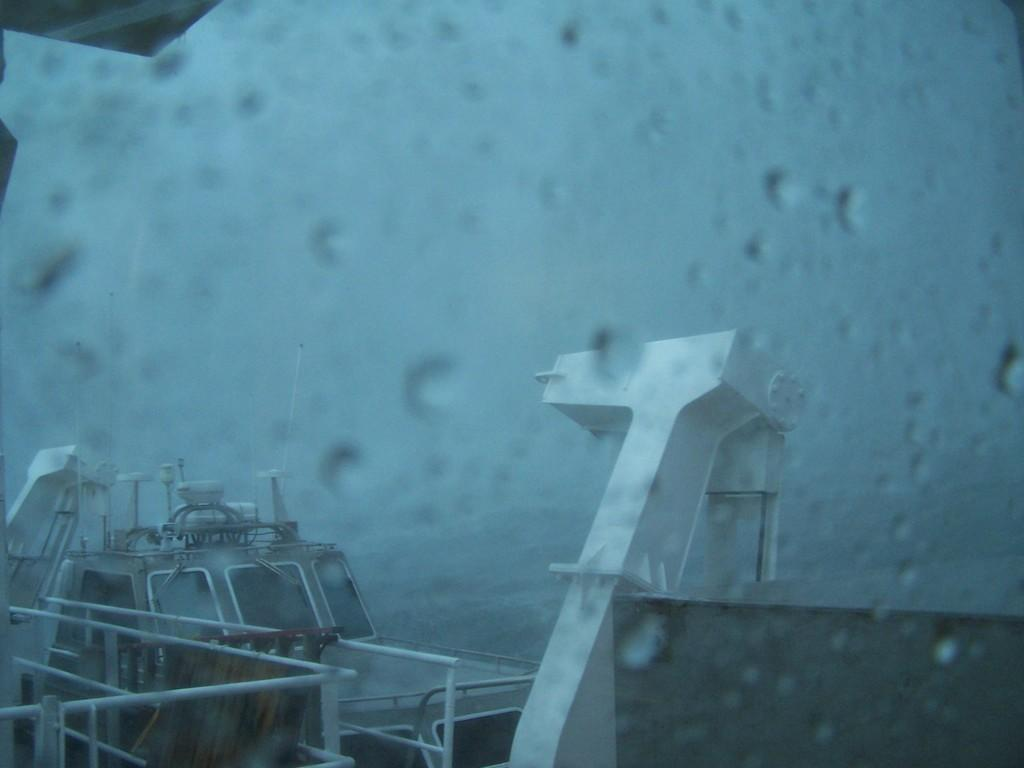What is the main subject of the image? The main subject of the image is ships. Where are the ships located? The ships are on the water. What else can be seen in the image besides the ships? The sky is visible in the image. What type of lumber is being used to build the ships in the image? There is no indication of the ships being built in the image, and no lumber is visible. How many spades are being used by the crew on the ships in the image? There are no spades visible in the image, and no crew members are shown. 